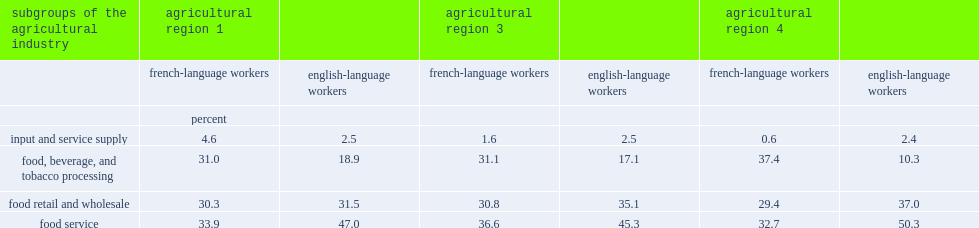Which sector of workers had more workers in the food, beverage and tobacco product manufacturing sectors? french-language workers or english-language workers? French-language workers. Which sector of workers had fewer workers in new brunswick's food retail and wholesale sector and food services sector? french-language workers or english-language workers? French-language workers. 